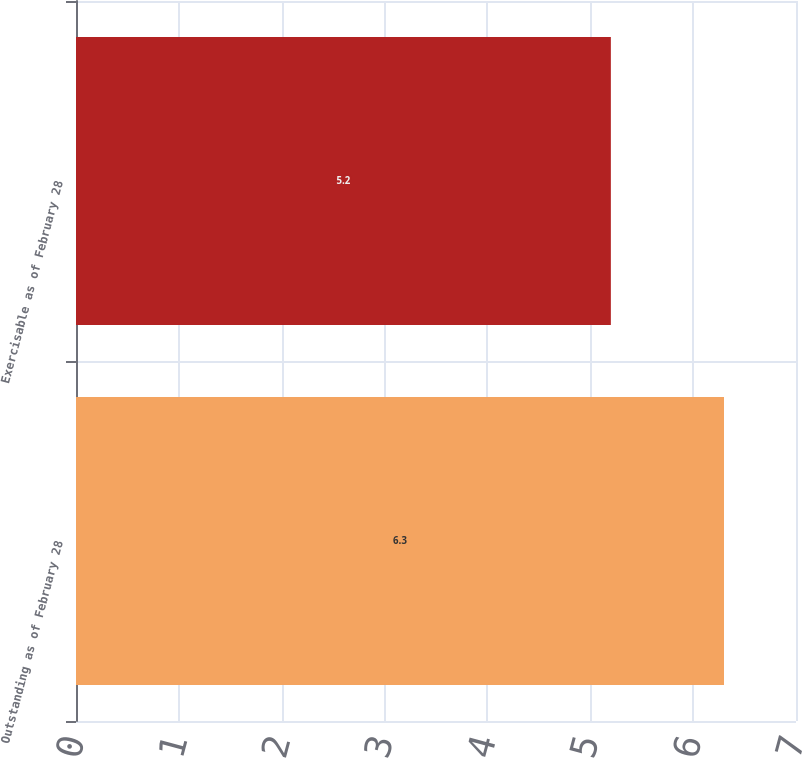<chart> <loc_0><loc_0><loc_500><loc_500><bar_chart><fcel>Outstanding as of February 28<fcel>Exercisable as of February 28<nl><fcel>6.3<fcel>5.2<nl></chart> 